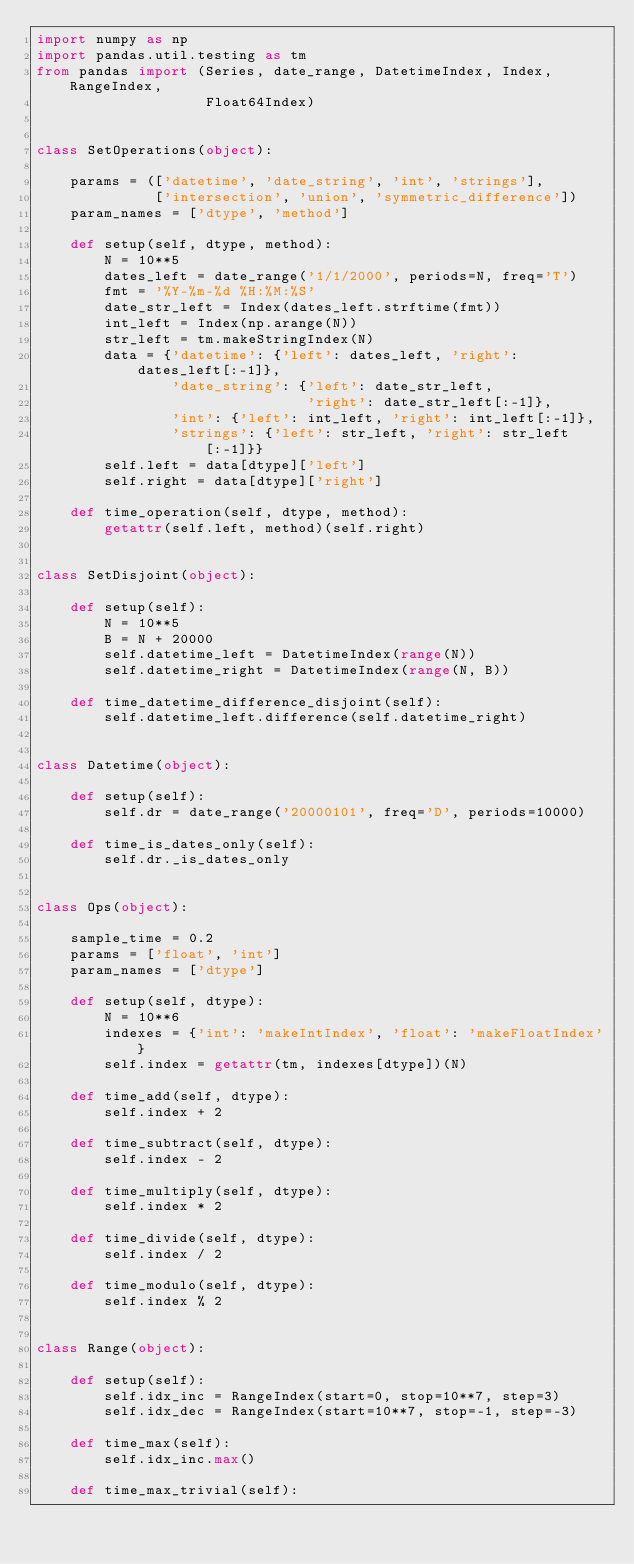Convert code to text. <code><loc_0><loc_0><loc_500><loc_500><_Python_>import numpy as np
import pandas.util.testing as tm
from pandas import (Series, date_range, DatetimeIndex, Index, RangeIndex,
                    Float64Index)


class SetOperations(object):

    params = (['datetime', 'date_string', 'int', 'strings'],
              ['intersection', 'union', 'symmetric_difference'])
    param_names = ['dtype', 'method']

    def setup(self, dtype, method):
        N = 10**5
        dates_left = date_range('1/1/2000', periods=N, freq='T')
        fmt = '%Y-%m-%d %H:%M:%S'
        date_str_left = Index(dates_left.strftime(fmt))
        int_left = Index(np.arange(N))
        str_left = tm.makeStringIndex(N)
        data = {'datetime': {'left': dates_left, 'right': dates_left[:-1]},
                'date_string': {'left': date_str_left,
                                'right': date_str_left[:-1]},
                'int': {'left': int_left, 'right': int_left[:-1]},
                'strings': {'left': str_left, 'right': str_left[:-1]}}
        self.left = data[dtype]['left']
        self.right = data[dtype]['right']

    def time_operation(self, dtype, method):
        getattr(self.left, method)(self.right)


class SetDisjoint(object):

    def setup(self):
        N = 10**5
        B = N + 20000
        self.datetime_left = DatetimeIndex(range(N))
        self.datetime_right = DatetimeIndex(range(N, B))

    def time_datetime_difference_disjoint(self):
        self.datetime_left.difference(self.datetime_right)


class Datetime(object):

    def setup(self):
        self.dr = date_range('20000101', freq='D', periods=10000)

    def time_is_dates_only(self):
        self.dr._is_dates_only


class Ops(object):

    sample_time = 0.2
    params = ['float', 'int']
    param_names = ['dtype']

    def setup(self, dtype):
        N = 10**6
        indexes = {'int': 'makeIntIndex', 'float': 'makeFloatIndex'}
        self.index = getattr(tm, indexes[dtype])(N)

    def time_add(self, dtype):
        self.index + 2

    def time_subtract(self, dtype):
        self.index - 2

    def time_multiply(self, dtype):
        self.index * 2

    def time_divide(self, dtype):
        self.index / 2

    def time_modulo(self, dtype):
        self.index % 2


class Range(object):

    def setup(self):
        self.idx_inc = RangeIndex(start=0, stop=10**7, step=3)
        self.idx_dec = RangeIndex(start=10**7, stop=-1, step=-3)

    def time_max(self):
        self.idx_inc.max()

    def time_max_trivial(self):</code> 